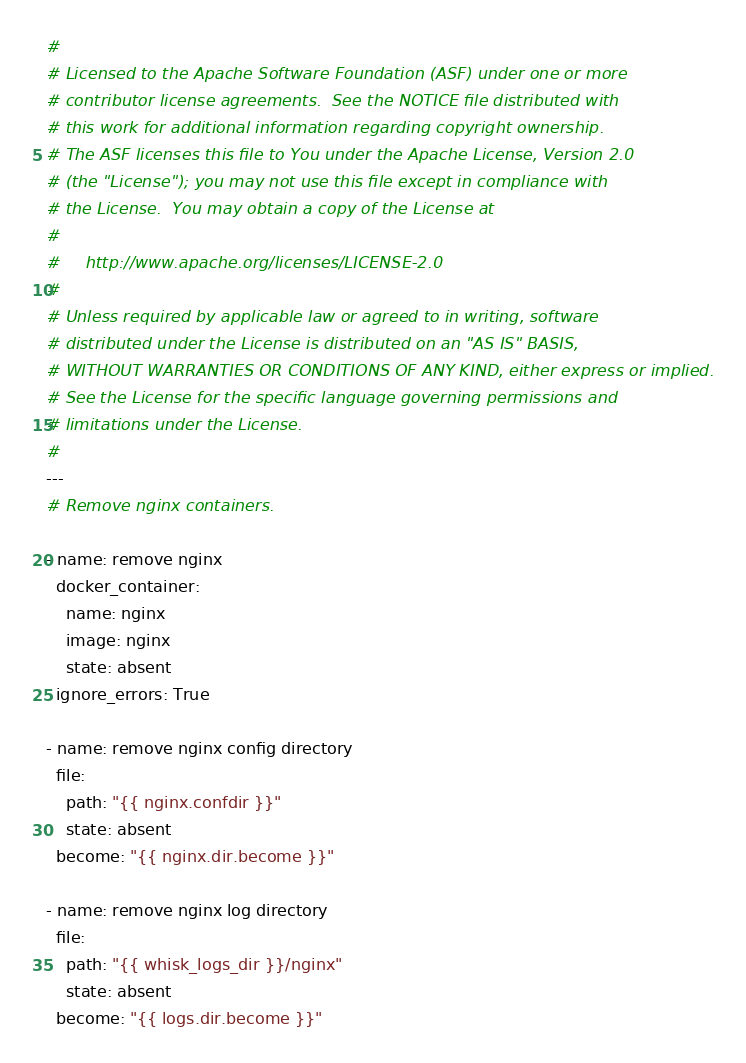<code> <loc_0><loc_0><loc_500><loc_500><_YAML_>#
# Licensed to the Apache Software Foundation (ASF) under one or more
# contributor license agreements.  See the NOTICE file distributed with
# this work for additional information regarding copyright ownership.
# The ASF licenses this file to You under the Apache License, Version 2.0
# (the "License"); you may not use this file except in compliance with
# the License.  You may obtain a copy of the License at
#
#     http://www.apache.org/licenses/LICENSE-2.0
#
# Unless required by applicable law or agreed to in writing, software
# distributed under the License is distributed on an "AS IS" BASIS,
# WITHOUT WARRANTIES OR CONDITIONS OF ANY KIND, either express or implied.
# See the License for the specific language governing permissions and
# limitations under the License.
#
---
# Remove nginx containers.

- name: remove nginx
  docker_container:
    name: nginx
    image: nginx
    state: absent
  ignore_errors: True

- name: remove nginx config directory
  file:
    path: "{{ nginx.confdir }}"
    state: absent
  become: "{{ nginx.dir.become }}"

- name: remove nginx log directory
  file:
    path: "{{ whisk_logs_dir }}/nginx"
    state: absent
  become: "{{ logs.dir.become }}"
</code> 